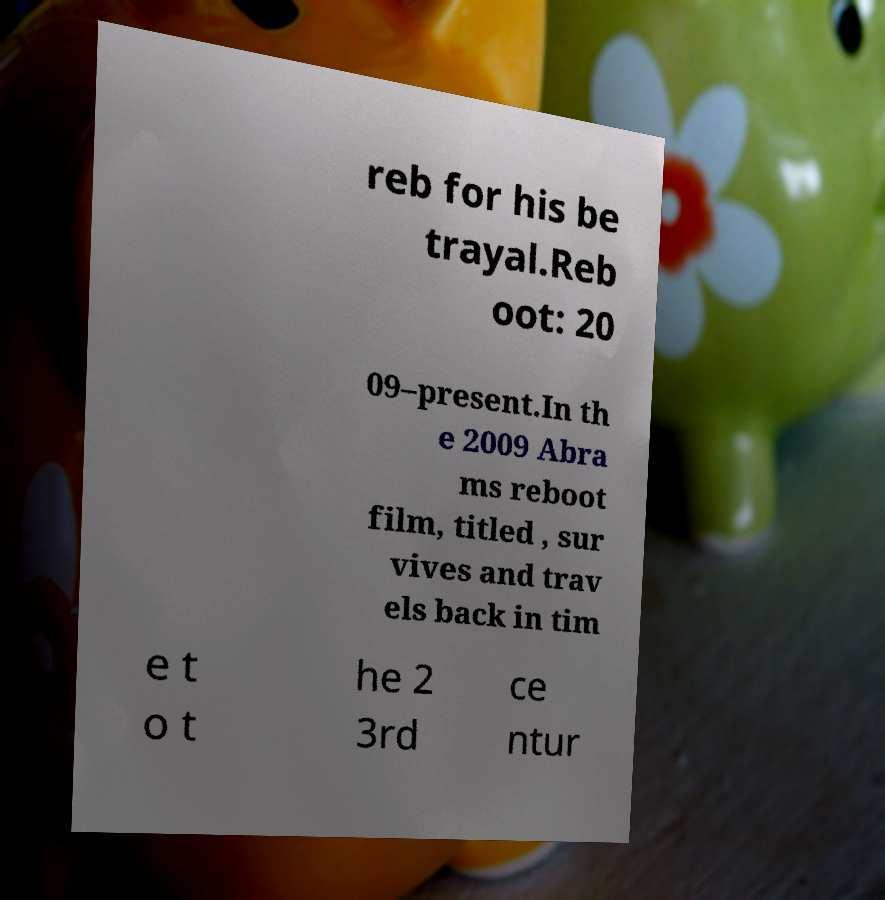Could you extract and type out the text from this image? reb for his be trayal.Reb oot: 20 09–present.In th e 2009 Abra ms reboot film, titled , sur vives and trav els back in tim e t o t he 2 3rd ce ntur 